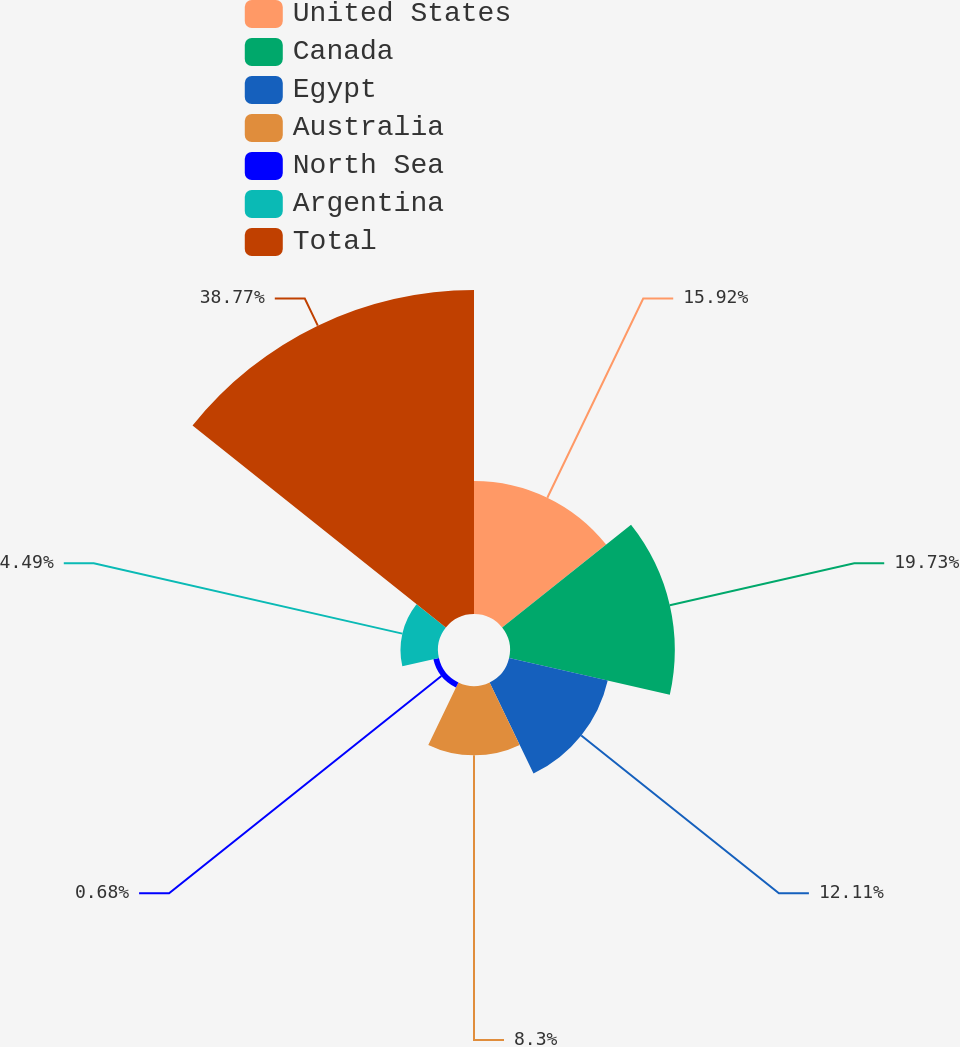Convert chart. <chart><loc_0><loc_0><loc_500><loc_500><pie_chart><fcel>United States<fcel>Canada<fcel>Egypt<fcel>Australia<fcel>North Sea<fcel>Argentina<fcel>Total<nl><fcel>15.92%<fcel>19.73%<fcel>12.11%<fcel>8.3%<fcel>0.68%<fcel>4.49%<fcel>38.78%<nl></chart> 